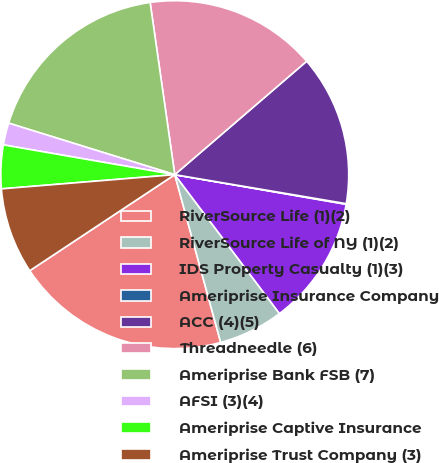Convert chart. <chart><loc_0><loc_0><loc_500><loc_500><pie_chart><fcel>RiverSource Life (1)(2)<fcel>RiverSource Life of NY (1)(2)<fcel>IDS Property Casualty (1)(3)<fcel>Ameriprise Insurance Company<fcel>ACC (4)(5)<fcel>Threadneedle (6)<fcel>Ameriprise Bank FSB (7)<fcel>AFSI (3)(4)<fcel>Ameriprise Captive Insurance<fcel>Ameriprise Trust Company (3)<nl><fcel>19.94%<fcel>6.03%<fcel>11.99%<fcel>0.06%<fcel>13.97%<fcel>15.96%<fcel>17.95%<fcel>2.05%<fcel>4.04%<fcel>8.01%<nl></chart> 